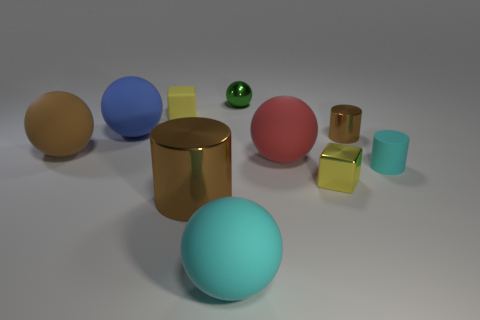Subtract all cyan balls. How many balls are left? 4 Subtract 1 cylinders. How many cylinders are left? 2 Subtract all cyan cylinders. How many cylinders are left? 2 Add 5 big blue metallic cylinders. How many big blue metallic cylinders exist? 5 Subtract 1 green spheres. How many objects are left? 9 Subtract all cylinders. How many objects are left? 7 Subtract all gray cylinders. Subtract all yellow cubes. How many cylinders are left? 3 Subtract all blue blocks. How many cyan cylinders are left? 1 Subtract all large red matte cylinders. Subtract all small yellow metallic things. How many objects are left? 9 Add 4 big red things. How many big red things are left? 5 